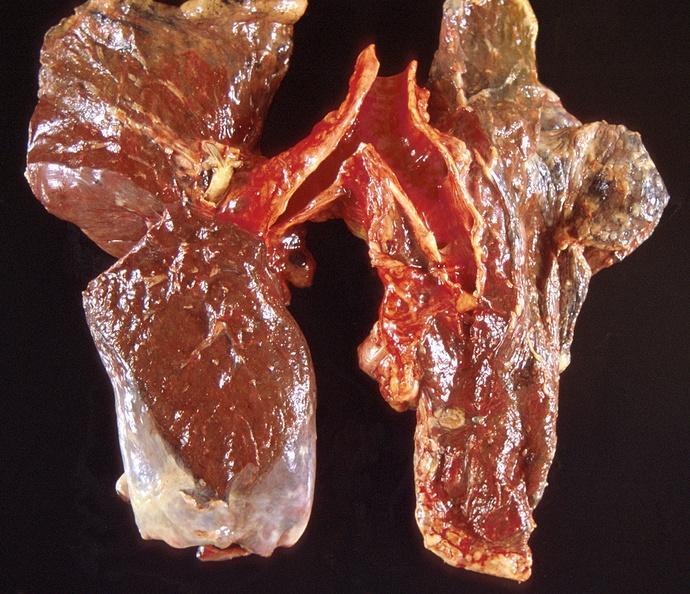does this image show lung carcinoma?
Answer the question using a single word or phrase. Yes 